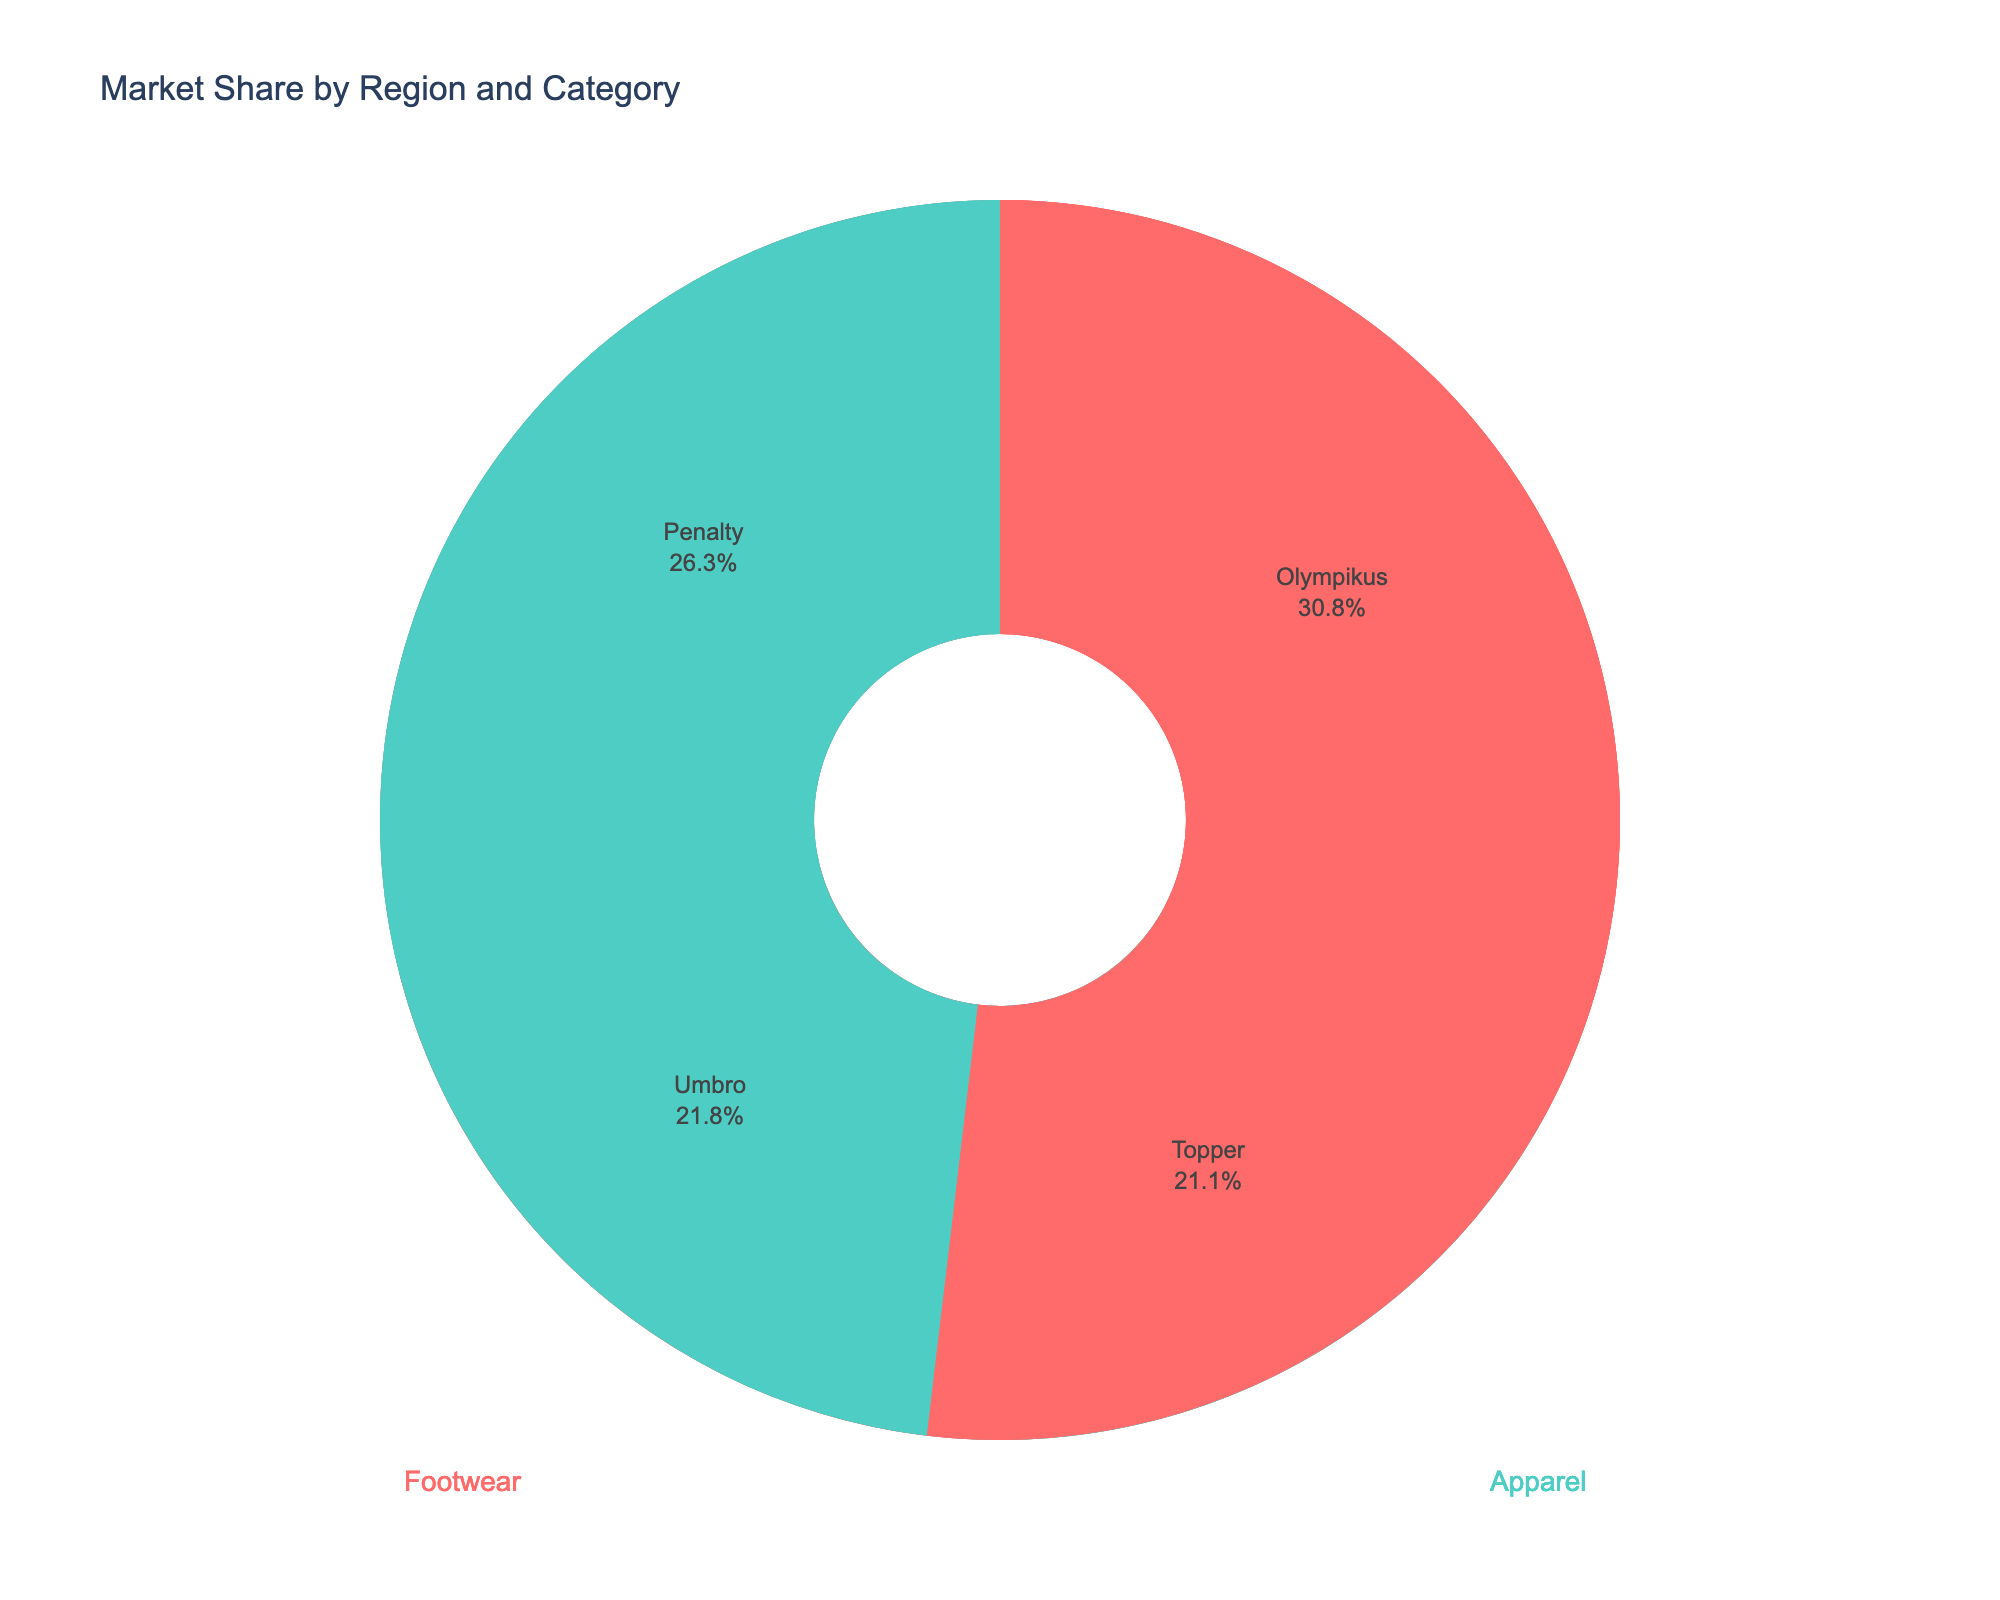Which region has the largest market share for Under Armour? By looking at the North America subplot and the label for Under Armour, we can see that Under Armour has a noticeable presence. Comparing its percentage to other regions, it is clear North America has the largest market share for Under Armour.
Answer: North America How much revenue is generated by Lululemon in North America? By examining the North America subplot, we can hover over or look for the label of Lululemon. The hover info or text displays a revenue of $410 million.
Answer: $410 million What's the combined market share of Li-Ning and Mizuno in Asia? In the Asia subplot, observe the market shares for Li-Ning and Mizuno. Li-Ning has 6.5% and Mizuno has 4.3%. Adding these gives: 6.5 + 4.3 = 10.8%
Answer: 10.8% Compare the market shares in Apparel category between Europe and Asia. Which region has the higher total? For Europe, the market shares for Apparel (Fila = 3.8% and Hummel = 2.5%) sum to 3.8 + 2.5 = 6.3%. For Asia, the market shares for Apparel (Anta = 5.7% and 361 Degrees = 3.2%) sum to 5.7 + 3.2 = 8.9%. Therefore, Asia has the higher total market share in the Apparel category.
Answer: Asia Which brand in the South America subplot has the smallest market share? By looking at the South America subplot, we see that Topper has the smallest market share at 2.8%.
Answer: Topper How does the market share of Skechers in Europe compare to Olympikus in South America? In the Europe subplot, Skechers has a market share of 4.7%, and in the South America subplot, Olympikus has a market share of 4.1%. Thus, Skechers has a slightly larger market share than Olympikus.
Answer: Skechers has a larger market share Is the market share of Fila in Europe higher than Penalty in South America? Within the Europe subplot, Fila has a market share of 3.8%, whereas in the South America subplot, Penalty's market share is 3.5%. Comparing these values, Fila's market share is slightly higher than Penalty's.
Answer: Yes What's the average revenue of the brands in the Europe region? First identify the revenues for brands in the Europe region: Asics ($310M), Skechers ($250M), Fila ($200M), and Hummel ($130M). Summing these gives 310 + 250 + 200 + 130 = $890M. Dividing by the 4 brands: 890 / 4 = $222.5M
Answer: $222.5M Which brand in the Asia subplot generates the highest revenue? By looking at the Asia subplot and checking each brand's revenue, we see that Li-Ning has the highest revenue with $340 million.
Answer: Li-Ning 